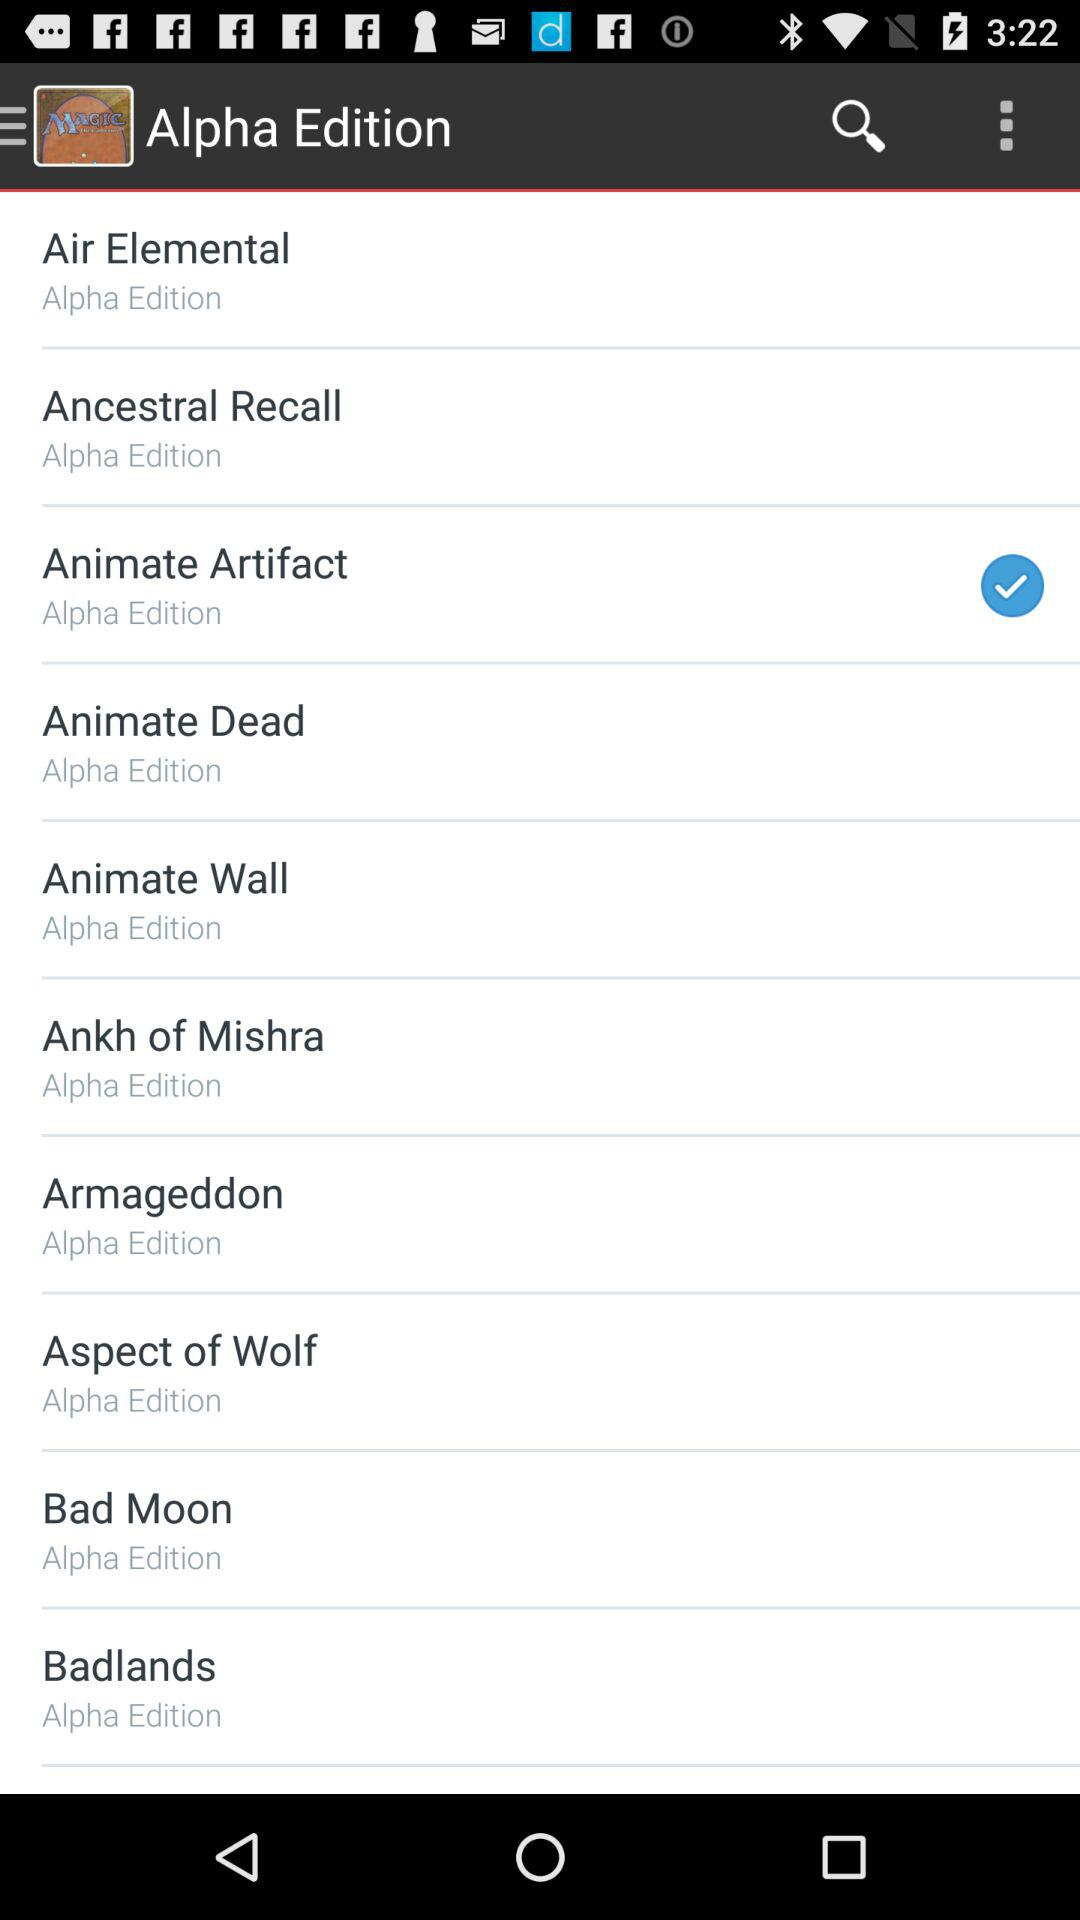What is the name of the application? The name of the application "Alpha Edition". 